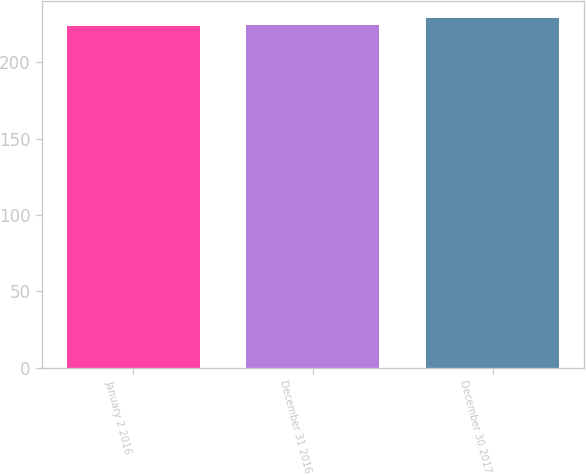<chart> <loc_0><loc_0><loc_500><loc_500><bar_chart><fcel>January 2 2016<fcel>December 31 2016<fcel>December 30 2017<nl><fcel>224<fcel>224.5<fcel>229<nl></chart> 